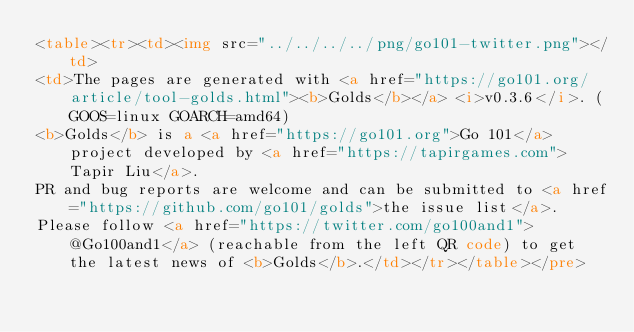<code> <loc_0><loc_0><loc_500><loc_500><_HTML_><table><tr><td><img src="../../../../png/go101-twitter.png"></td>
<td>The pages are generated with <a href="https://go101.org/article/tool-golds.html"><b>Golds</b></a> <i>v0.3.6</i>. (GOOS=linux GOARCH=amd64)
<b>Golds</b> is a <a href="https://go101.org">Go 101</a> project developed by <a href="https://tapirgames.com">Tapir Liu</a>.
PR and bug reports are welcome and can be submitted to <a href="https://github.com/go101/golds">the issue list</a>.
Please follow <a href="https://twitter.com/go100and1">@Go100and1</a> (reachable from the left QR code) to get the latest news of <b>Golds</b>.</td></tr></table></pre></code> 